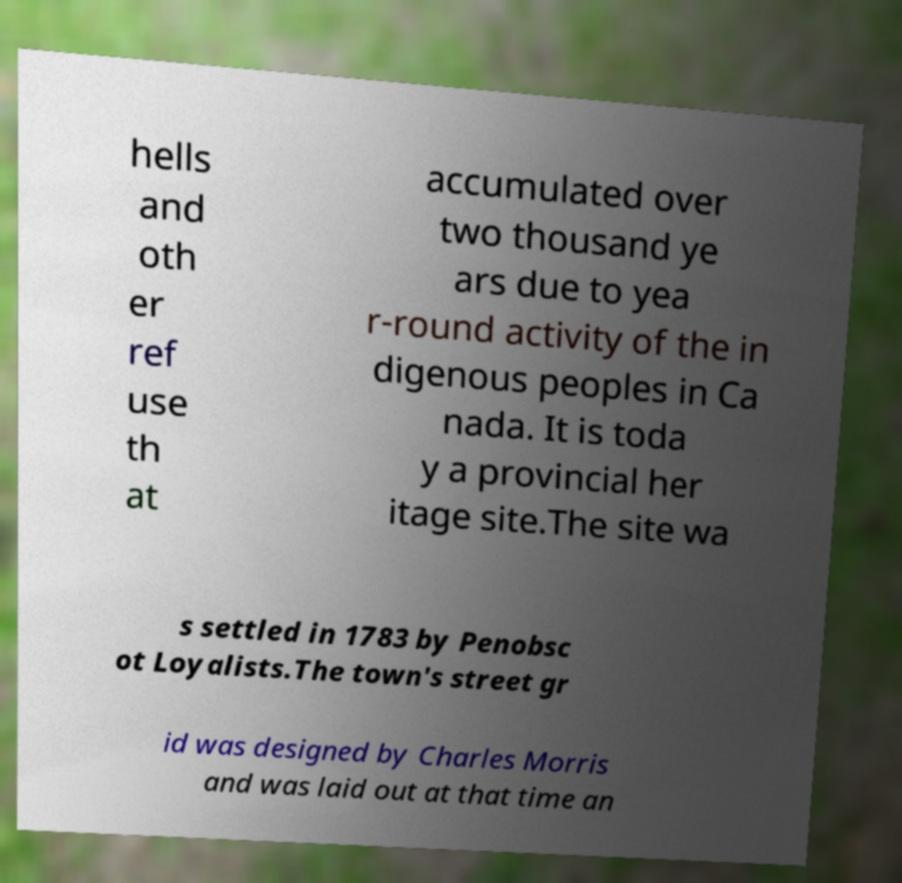Can you read and provide the text displayed in the image?This photo seems to have some interesting text. Can you extract and type it out for me? hells and oth er ref use th at accumulated over two thousand ye ars due to yea r-round activity of the in digenous peoples in Ca nada. It is toda y a provincial her itage site.The site wa s settled in 1783 by Penobsc ot Loyalists.The town's street gr id was designed by Charles Morris and was laid out at that time an 